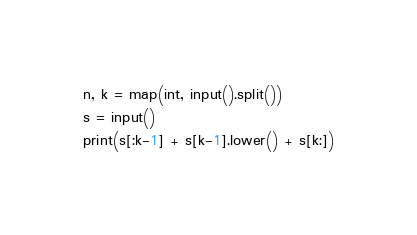Convert code to text. <code><loc_0><loc_0><loc_500><loc_500><_Python_>n, k = map(int, input().split())
s = input()
print(s[:k-1] + s[k-1].lower() + s[k:])
</code> 